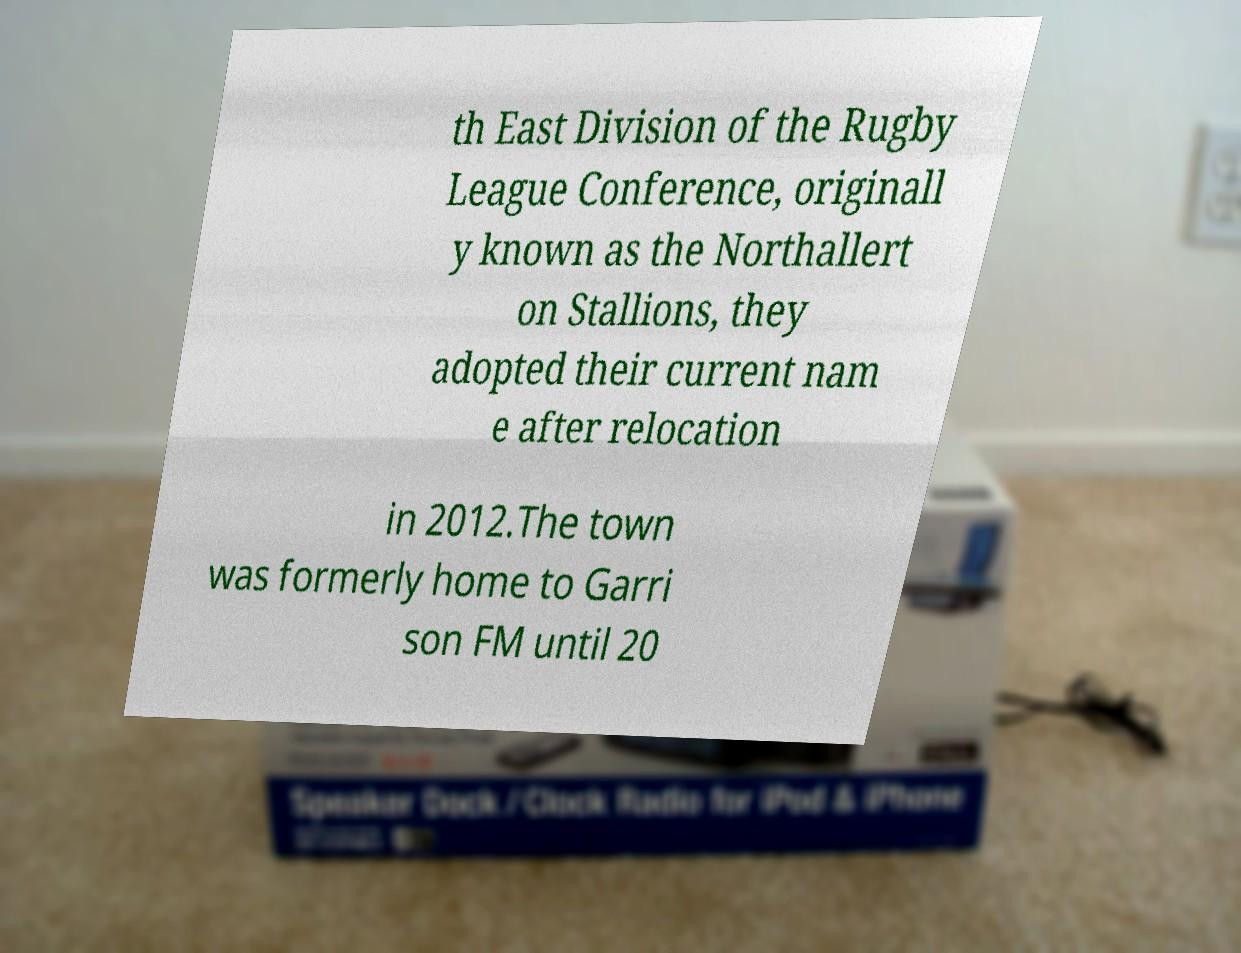Could you extract and type out the text from this image? th East Division of the Rugby League Conference, originall y known as the Northallert on Stallions, they adopted their current nam e after relocation in 2012.The town was formerly home to Garri son FM until 20 